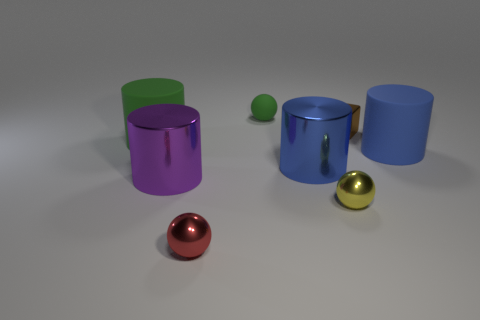What shape is the yellow object? sphere 